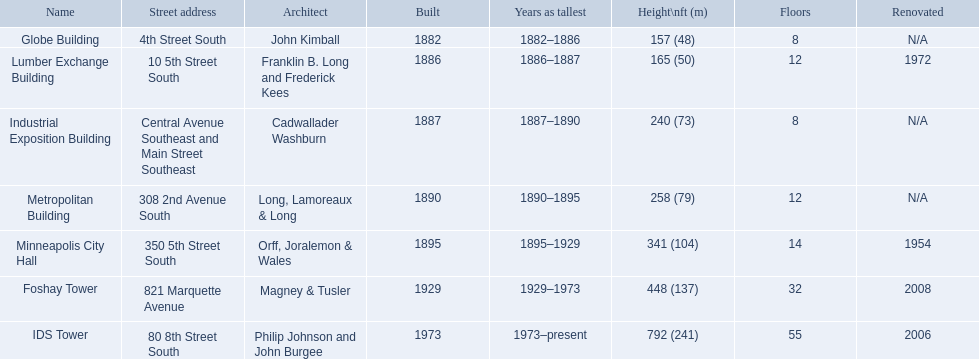What are the tallest buildings in minneapolis? Globe Building, Lumber Exchange Building, Industrial Exposition Building, Metropolitan Building, Minneapolis City Hall, Foshay Tower, IDS Tower. Which of those have 8 floors? Globe Building, Industrial Exposition Building. Of those, which is 240 ft tall? Industrial Exposition Building. 